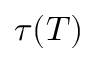<formula> <loc_0><loc_0><loc_500><loc_500>\tau ( T )</formula> 